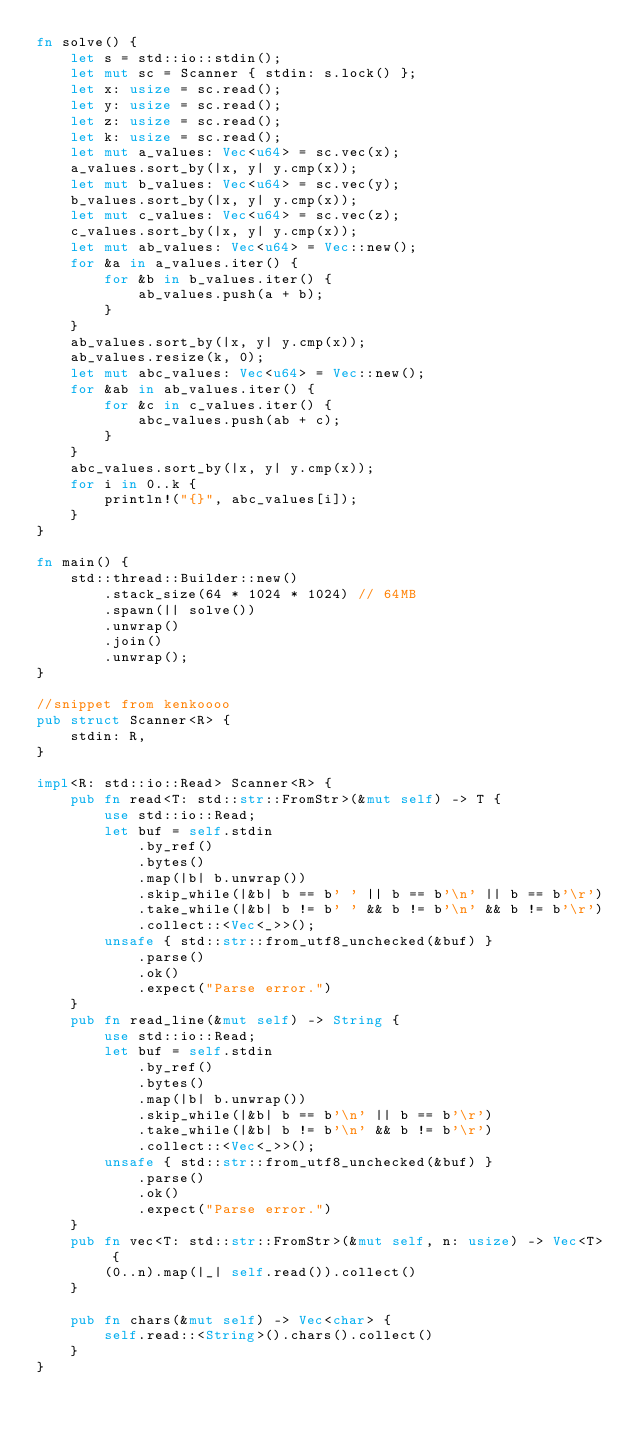<code> <loc_0><loc_0><loc_500><loc_500><_Rust_>fn solve() {
    let s = std::io::stdin();
    let mut sc = Scanner { stdin: s.lock() };
    let x: usize = sc.read();
    let y: usize = sc.read();
    let z: usize = sc.read();
    let k: usize = sc.read();
    let mut a_values: Vec<u64> = sc.vec(x);
    a_values.sort_by(|x, y| y.cmp(x));
    let mut b_values: Vec<u64> = sc.vec(y);
    b_values.sort_by(|x, y| y.cmp(x));
    let mut c_values: Vec<u64> = sc.vec(z);
    c_values.sort_by(|x, y| y.cmp(x));
    let mut ab_values: Vec<u64> = Vec::new();
    for &a in a_values.iter() {
        for &b in b_values.iter() {
            ab_values.push(a + b);
        }
    }
    ab_values.sort_by(|x, y| y.cmp(x));
    ab_values.resize(k, 0);
    let mut abc_values: Vec<u64> = Vec::new();
    for &ab in ab_values.iter() {
        for &c in c_values.iter() {
            abc_values.push(ab + c);
        }
    }
    abc_values.sort_by(|x, y| y.cmp(x));
    for i in 0..k {
        println!("{}", abc_values[i]);
    }
}

fn main() {
    std::thread::Builder::new()
        .stack_size(64 * 1024 * 1024) // 64MB
        .spawn(|| solve())
        .unwrap()
        .join()
        .unwrap();
}

//snippet from kenkoooo
pub struct Scanner<R> {
    stdin: R,
}

impl<R: std::io::Read> Scanner<R> {
    pub fn read<T: std::str::FromStr>(&mut self) -> T {
        use std::io::Read;
        let buf = self.stdin
            .by_ref()
            .bytes()
            .map(|b| b.unwrap())
            .skip_while(|&b| b == b' ' || b == b'\n' || b == b'\r')
            .take_while(|&b| b != b' ' && b != b'\n' && b != b'\r')
            .collect::<Vec<_>>();
        unsafe { std::str::from_utf8_unchecked(&buf) }
            .parse()
            .ok()
            .expect("Parse error.")
    }
    pub fn read_line(&mut self) -> String {
        use std::io::Read;
        let buf = self.stdin
            .by_ref()
            .bytes()
            .map(|b| b.unwrap())
            .skip_while(|&b| b == b'\n' || b == b'\r')
            .take_while(|&b| b != b'\n' && b != b'\r')
            .collect::<Vec<_>>();
        unsafe { std::str::from_utf8_unchecked(&buf) }
            .parse()
            .ok()
            .expect("Parse error.")
    }
    pub fn vec<T: std::str::FromStr>(&mut self, n: usize) -> Vec<T> {
        (0..n).map(|_| self.read()).collect()
    }

    pub fn chars(&mut self) -> Vec<char> {
        self.read::<String>().chars().collect()
    }
}
</code> 